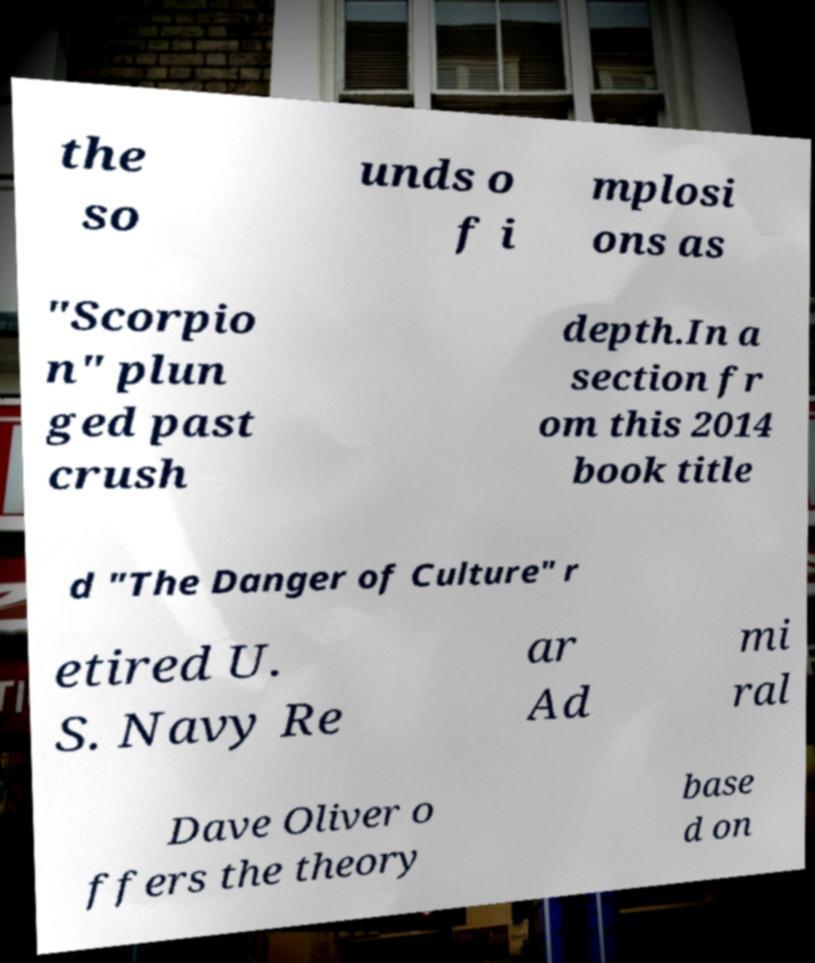Please read and relay the text visible in this image. What does it say? the so unds o f i mplosi ons as "Scorpio n" plun ged past crush depth.In a section fr om this 2014 book title d "The Danger of Culture" r etired U. S. Navy Re ar Ad mi ral Dave Oliver o ffers the theory base d on 